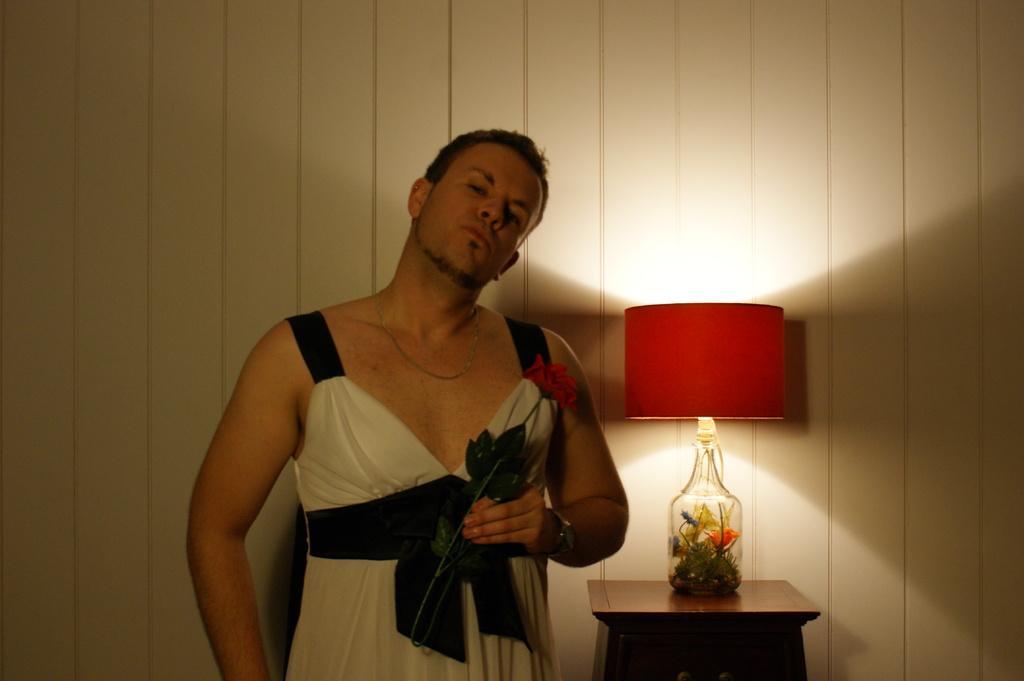Could you give a brief overview of what you see in this image? This picture is taken inside a room. There is a man standing and holding a rose in his left hand. He also wore a gown and a watch to his left hand. Behind him there is table on which there is a jar and flowers are placed in it and on it a lamp is placed. In the background there is a wall. 